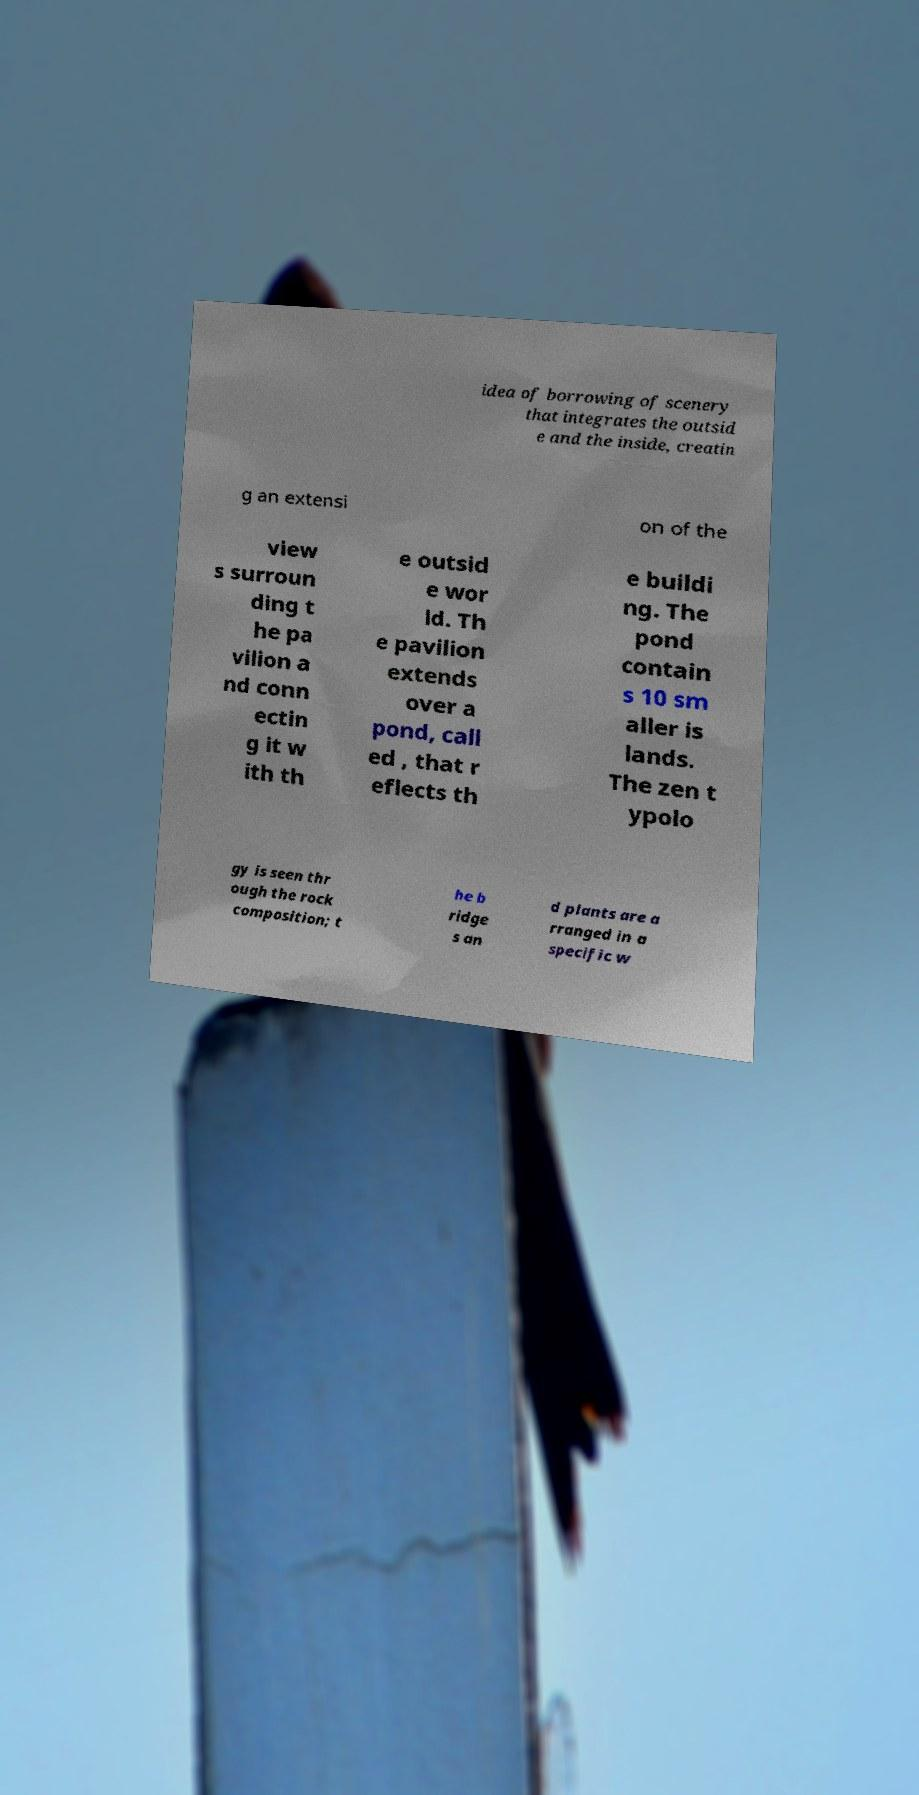Could you extract and type out the text from this image? idea of borrowing of scenery that integrates the outsid e and the inside, creatin g an extensi on of the view s surroun ding t he pa vilion a nd conn ectin g it w ith th e outsid e wor ld. Th e pavilion extends over a pond, call ed , that r eflects th e buildi ng. The pond contain s 10 sm aller is lands. The zen t ypolo gy is seen thr ough the rock composition; t he b ridge s an d plants are a rranged in a specific w 